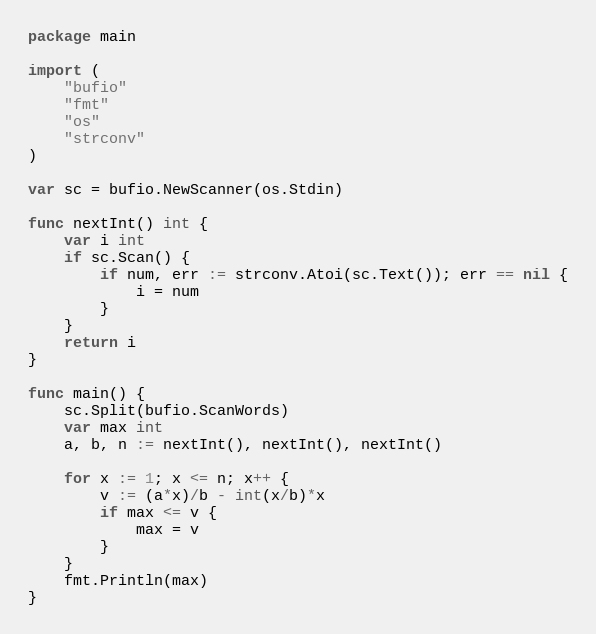Convert code to text. <code><loc_0><loc_0><loc_500><loc_500><_Go_>package main

import (
	"bufio"
	"fmt"
	"os"
	"strconv"
)

var sc = bufio.NewScanner(os.Stdin)

func nextInt() int {
	var i int
	if sc.Scan() {
		if num, err := strconv.Atoi(sc.Text()); err == nil {
			i = num
		}
	}
	return i
}

func main() {
	sc.Split(bufio.ScanWords)
	var max int
	a, b, n := nextInt(), nextInt(), nextInt()

	for x := 1; x <= n; x++ {
		v := (a*x)/b - int(x/b)*x
		if max <= v {
			max = v
		}
	}
	fmt.Println(max)
}
</code> 